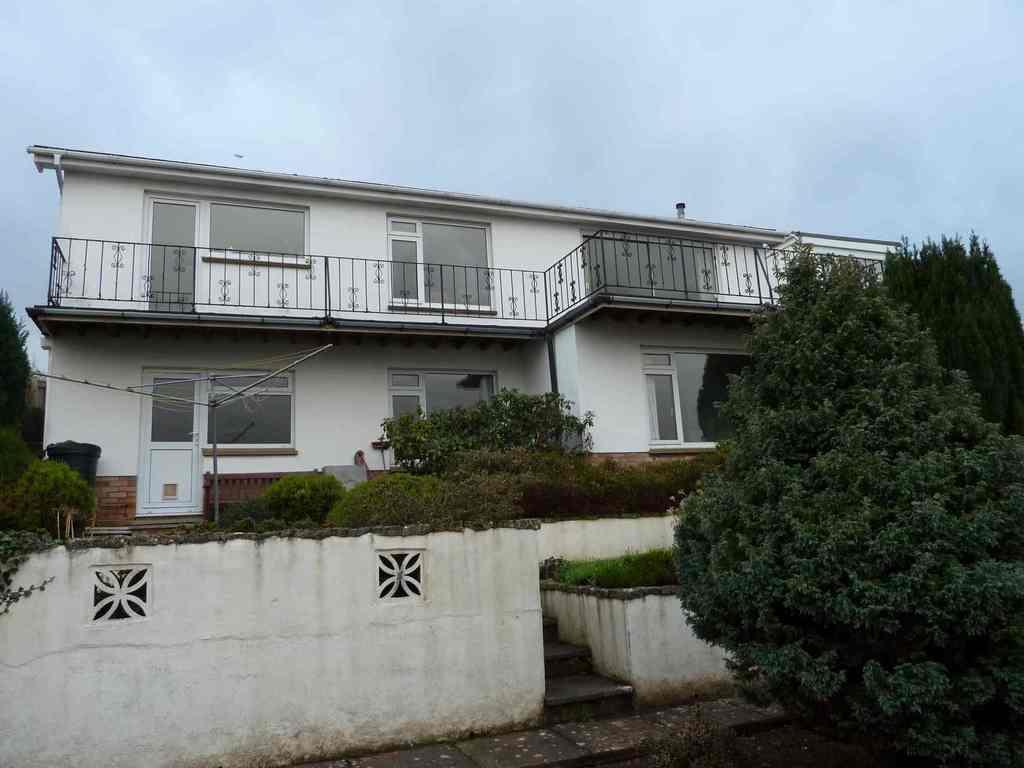Please provide a concise description of this image. It is the image of a house,in front of the house there is a lot of greenery and trees and in the background there is a sky. 